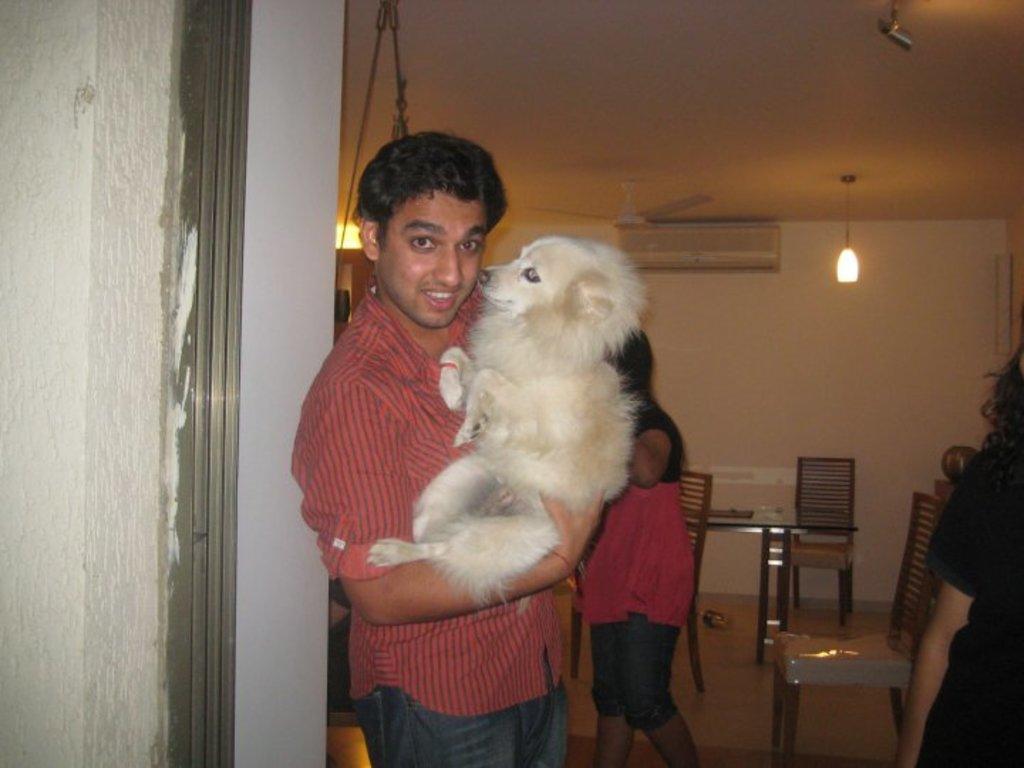Could you give a brief overview of what you see in this image? In this image there is a person wearing red color shirt catching a puppy in his hand and at the background of the image there is a fan,light and chair. 